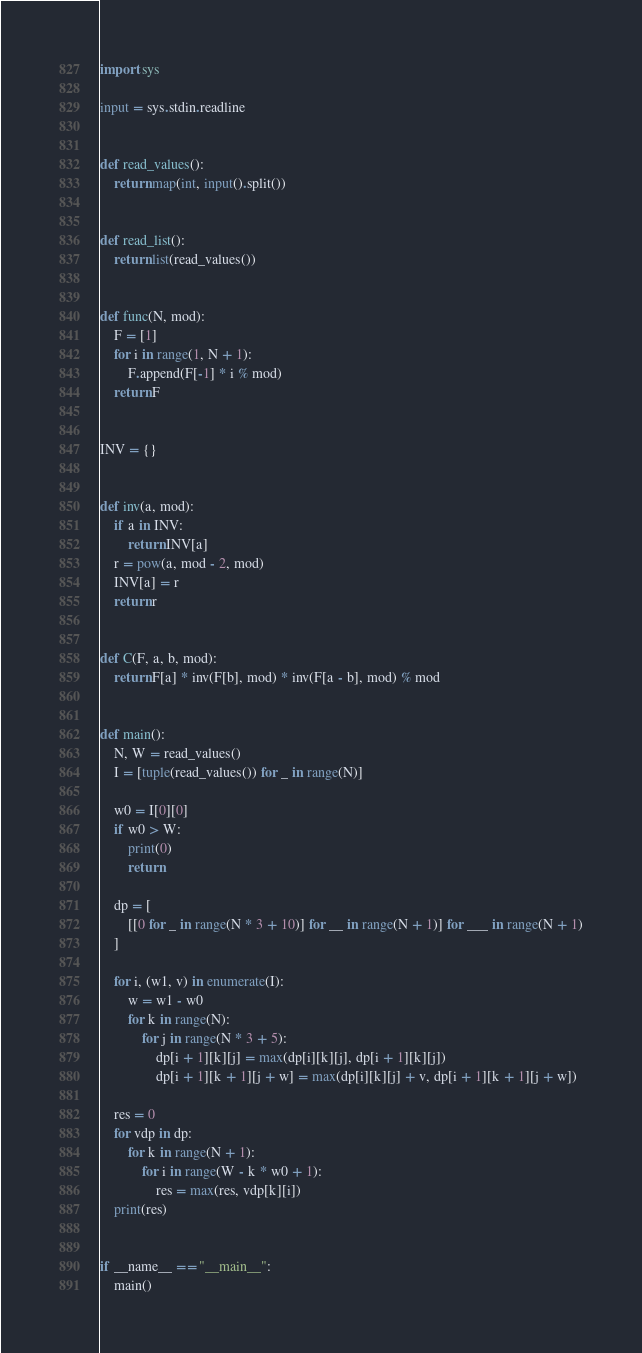<code> <loc_0><loc_0><loc_500><loc_500><_Python_>import sys

input = sys.stdin.readline


def read_values():
    return map(int, input().split())


def read_list():
    return list(read_values())


def func(N, mod):
    F = [1]
    for i in range(1, N + 1):
        F.append(F[-1] * i % mod)
    return F


INV = {}


def inv(a, mod):
    if a in INV:
        return INV[a]
    r = pow(a, mod - 2, mod)
    INV[a] = r
    return r


def C(F, a, b, mod):
    return F[a] * inv(F[b], mod) * inv(F[a - b], mod) % mod


def main():
    N, W = read_values()
    I = [tuple(read_values()) for _ in range(N)]

    w0 = I[0][0]
    if w0 > W:
        print(0)
        return

    dp = [
        [[0 for _ in range(N * 3 + 10)] for __ in range(N + 1)] for ___ in range(N + 1)
    ]

    for i, (w1, v) in enumerate(I):
        w = w1 - w0
        for k in range(N):
            for j in range(N * 3 + 5):
                dp[i + 1][k][j] = max(dp[i][k][j], dp[i + 1][k][j])
                dp[i + 1][k + 1][j + w] = max(dp[i][k][j] + v, dp[i + 1][k + 1][j + w])

    res = 0
    for vdp in dp:
        for k in range(N + 1):
            for i in range(W - k * w0 + 1):
                res = max(res, vdp[k][i])
    print(res)


if __name__ == "__main__":
    main()

</code> 